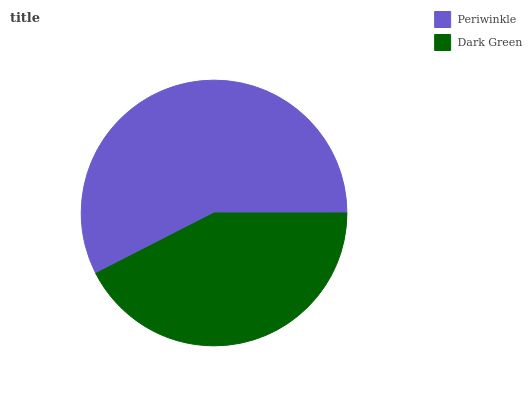Is Dark Green the minimum?
Answer yes or no. Yes. Is Periwinkle the maximum?
Answer yes or no. Yes. Is Dark Green the maximum?
Answer yes or no. No. Is Periwinkle greater than Dark Green?
Answer yes or no. Yes. Is Dark Green less than Periwinkle?
Answer yes or no. Yes. Is Dark Green greater than Periwinkle?
Answer yes or no. No. Is Periwinkle less than Dark Green?
Answer yes or no. No. Is Periwinkle the high median?
Answer yes or no. Yes. Is Dark Green the low median?
Answer yes or no. Yes. Is Dark Green the high median?
Answer yes or no. No. Is Periwinkle the low median?
Answer yes or no. No. 